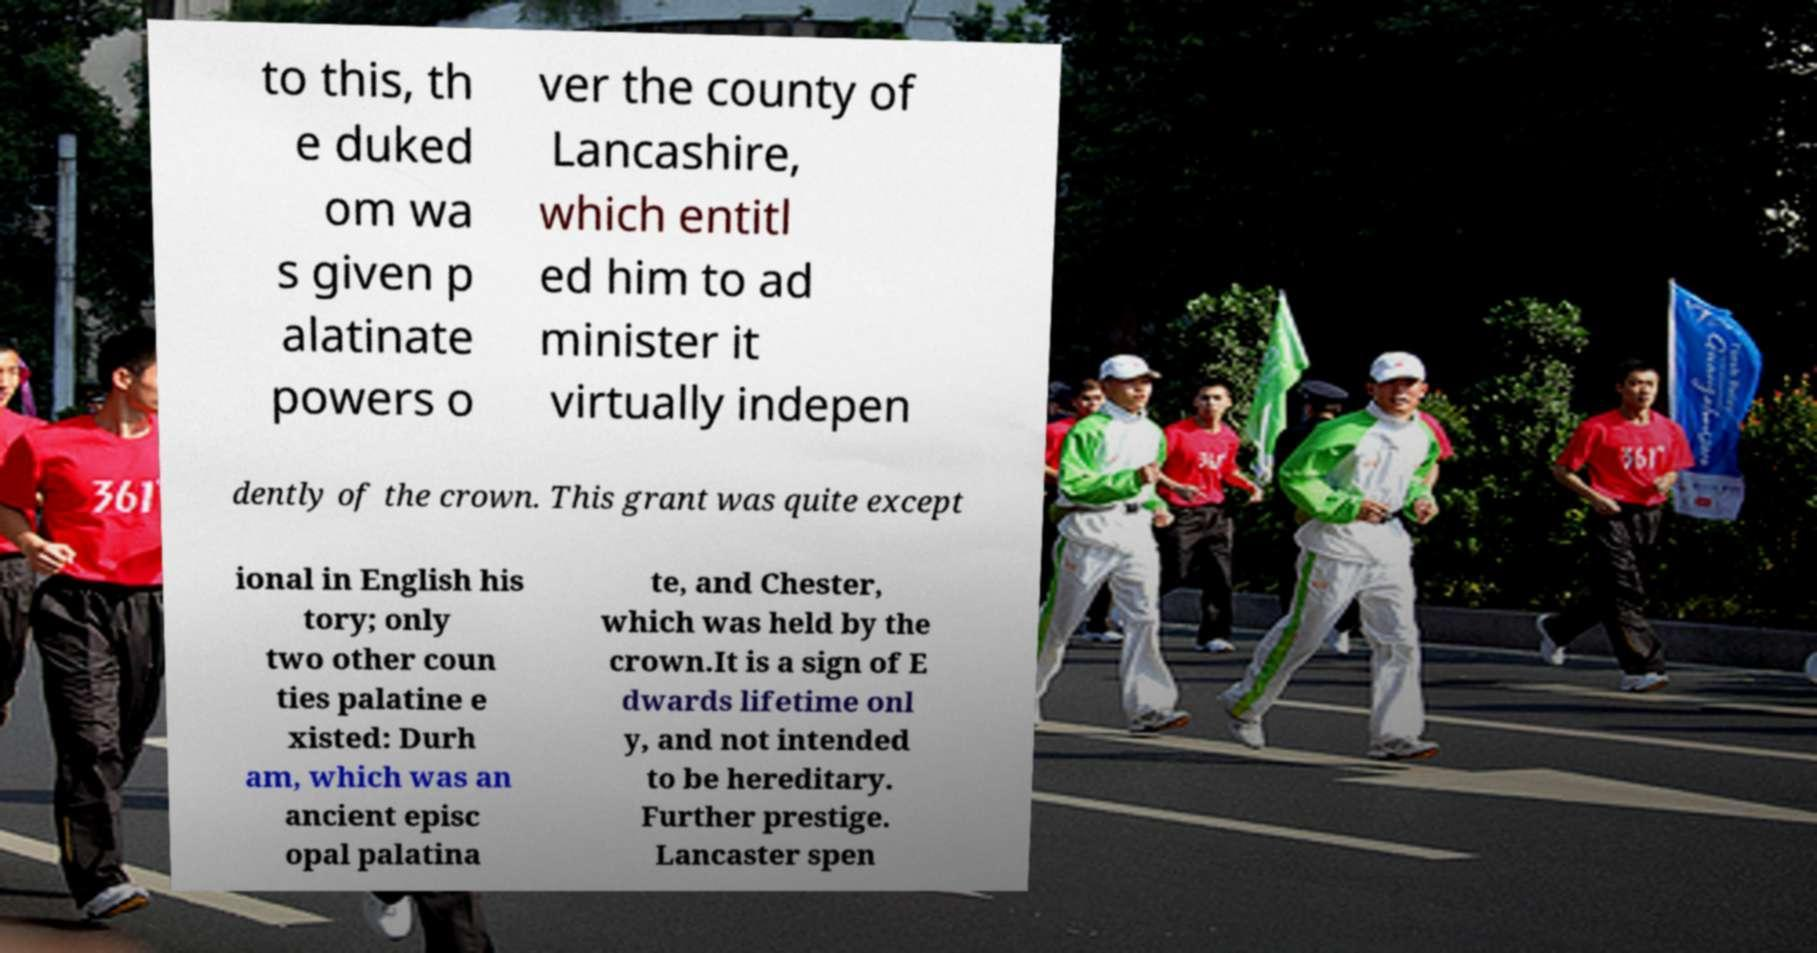Could you extract and type out the text from this image? to this, th e duked om wa s given p alatinate powers o ver the county of Lancashire, which entitl ed him to ad minister it virtually indepen dently of the crown. This grant was quite except ional in English his tory; only two other coun ties palatine e xisted: Durh am, which was an ancient episc opal palatina te, and Chester, which was held by the crown.It is a sign of E dwards lifetime onl y, and not intended to be hereditary. Further prestige. Lancaster spen 